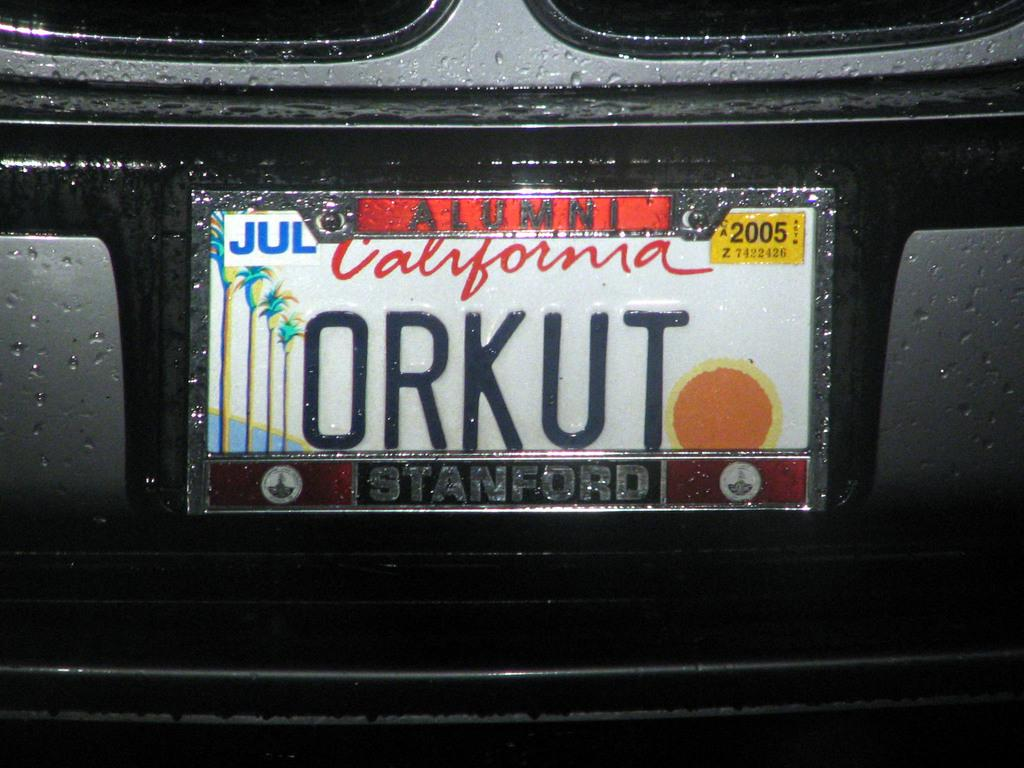<image>
Describe the image concisely. A picture California license  plate that says ORKUT. 